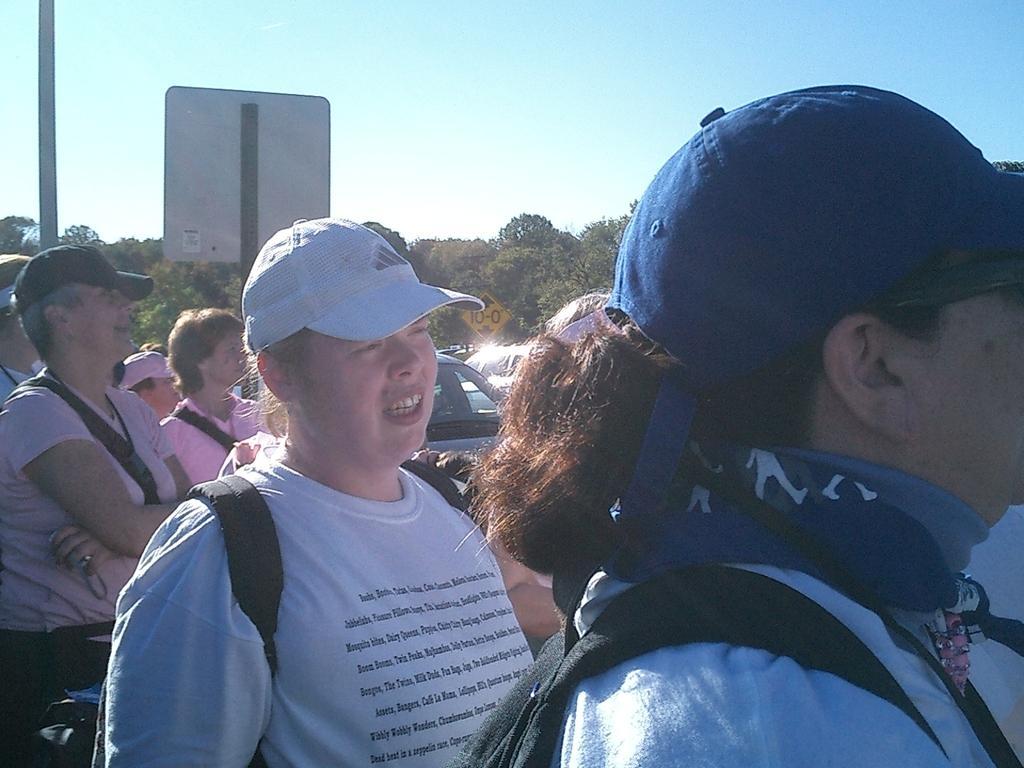Can you describe this image briefly? In this image we can see a group of people and some vehicles. We can also see a pole, the signboards, a group of trees and the sky. 